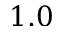Convert formula to latex. <formula><loc_0><loc_0><loc_500><loc_500>1 . 0</formula> 